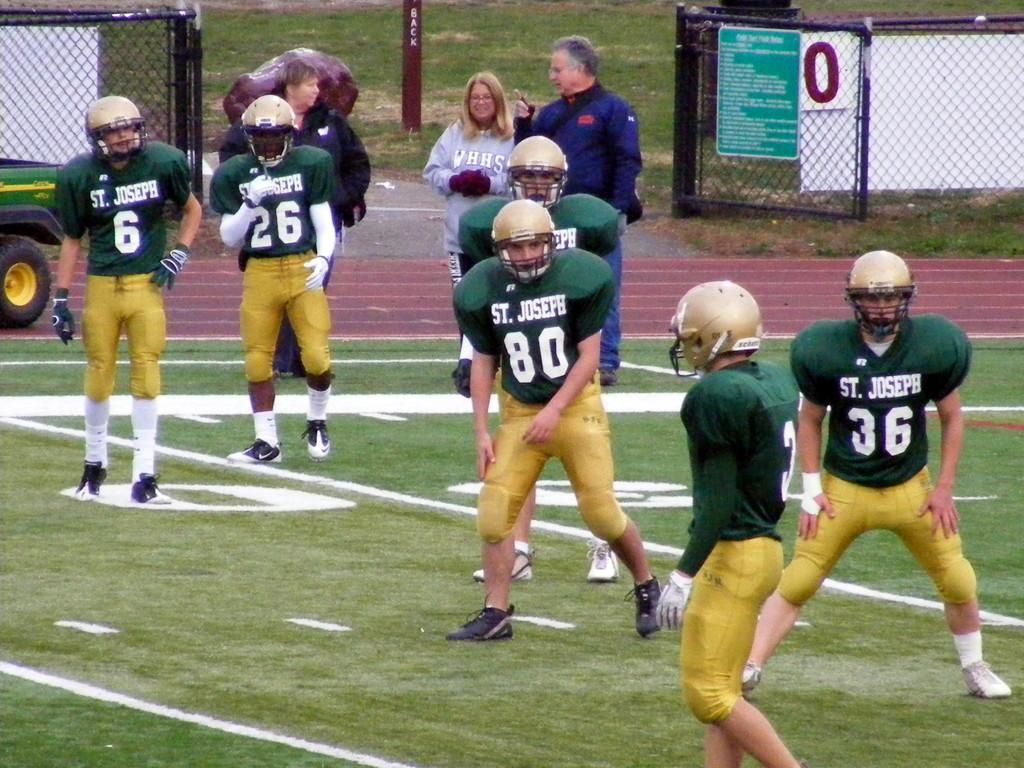Describe this image in one or two sentences. In this picture there are people, among them few people wore helmets and we can see grass,vehicle on the ground, gate, boards, meshes, rock and pole. 